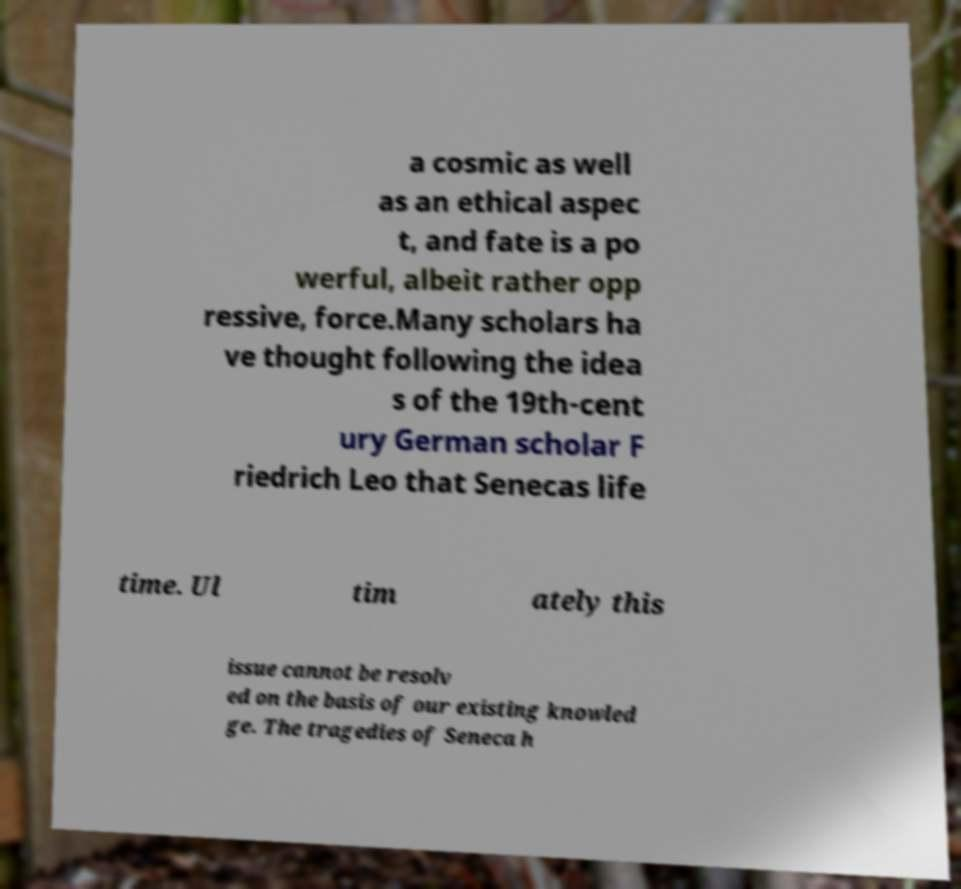Please identify and transcribe the text found in this image. a cosmic as well as an ethical aspec t, and fate is a po werful, albeit rather opp ressive, force.Many scholars ha ve thought following the idea s of the 19th-cent ury German scholar F riedrich Leo that Senecas life time. Ul tim ately this issue cannot be resolv ed on the basis of our existing knowled ge. The tragedies of Seneca h 